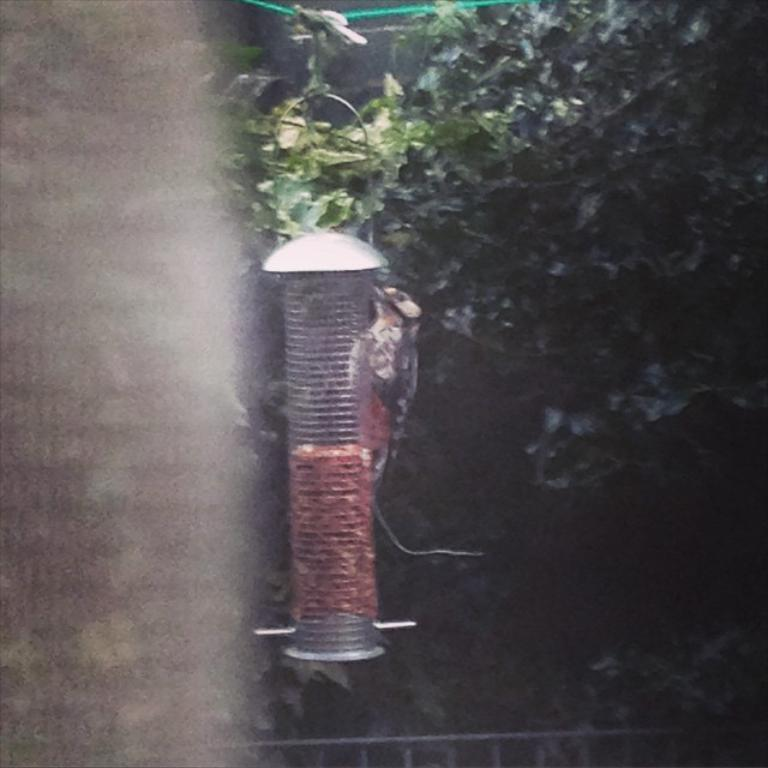What is the main object in the picture? There is a cage in the picture. Is there any living creature near the cage? Yes, a bird is standing by the cage. What can be seen in the background of the picture? There are trees visible in the background of the picture. What type of oatmeal is the bird eating in the picture? There is no oatmeal present in the picture; the bird is standing by the cage. Can you tell me who the guide is in the picture? There is no guide present in the picture; it features a bird standing by a cage and trees in the background. 